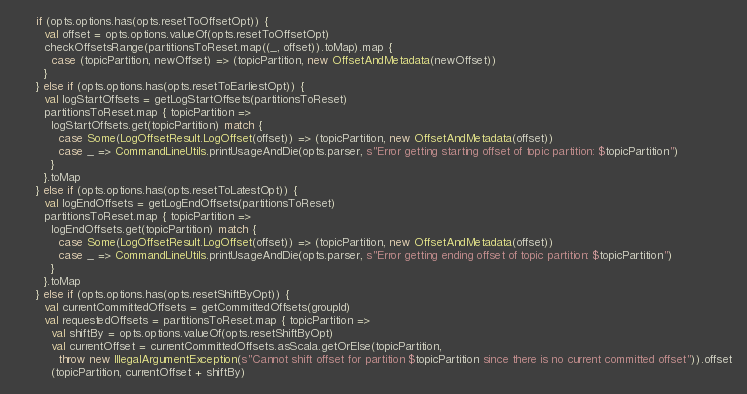Convert code to text. <code><loc_0><loc_0><loc_500><loc_500><_Scala_>      if (opts.options.has(opts.resetToOffsetOpt)) {
        val offset = opts.options.valueOf(opts.resetToOffsetOpt)
        checkOffsetsRange(partitionsToReset.map((_, offset)).toMap).map {
          case (topicPartition, newOffset) => (topicPartition, new OffsetAndMetadata(newOffset))
        }
      } else if (opts.options.has(opts.resetToEarliestOpt)) {
        val logStartOffsets = getLogStartOffsets(partitionsToReset)
        partitionsToReset.map { topicPartition =>
          logStartOffsets.get(topicPartition) match {
            case Some(LogOffsetResult.LogOffset(offset)) => (topicPartition, new OffsetAndMetadata(offset))
            case _ => CommandLineUtils.printUsageAndDie(opts.parser, s"Error getting starting offset of topic partition: $topicPartition")
          }
        }.toMap
      } else if (opts.options.has(opts.resetToLatestOpt)) {
        val logEndOffsets = getLogEndOffsets(partitionsToReset)
        partitionsToReset.map { topicPartition =>
          logEndOffsets.get(topicPartition) match {
            case Some(LogOffsetResult.LogOffset(offset)) => (topicPartition, new OffsetAndMetadata(offset))
            case _ => CommandLineUtils.printUsageAndDie(opts.parser, s"Error getting ending offset of topic partition: $topicPartition")
          }
        }.toMap
      } else if (opts.options.has(opts.resetShiftByOpt)) {
        val currentCommittedOffsets = getCommittedOffsets(groupId)
        val requestedOffsets = partitionsToReset.map { topicPartition =>
          val shiftBy = opts.options.valueOf(opts.resetShiftByOpt)
          val currentOffset = currentCommittedOffsets.asScala.getOrElse(topicPartition,
            throw new IllegalArgumentException(s"Cannot shift offset for partition $topicPartition since there is no current committed offset")).offset
          (topicPartition, currentOffset + shiftBy)</code> 